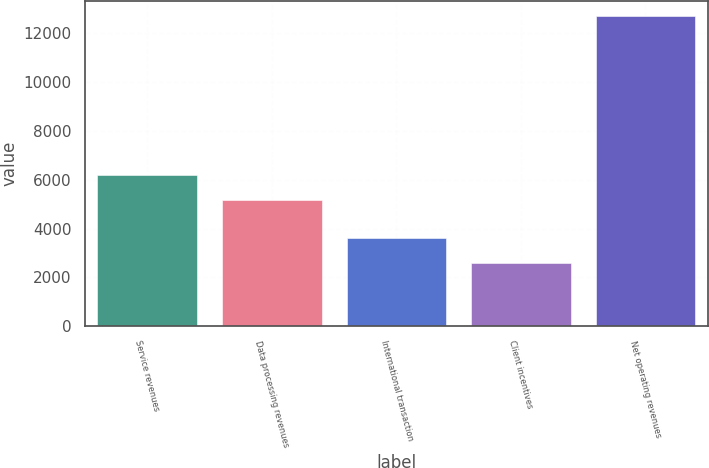Convert chart. <chart><loc_0><loc_0><loc_500><loc_500><bar_chart><fcel>Service revenues<fcel>Data processing revenues<fcel>International transaction<fcel>Client incentives<fcel>Net operating revenues<nl><fcel>6178<fcel>5167<fcel>3603<fcel>2592<fcel>12702<nl></chart> 